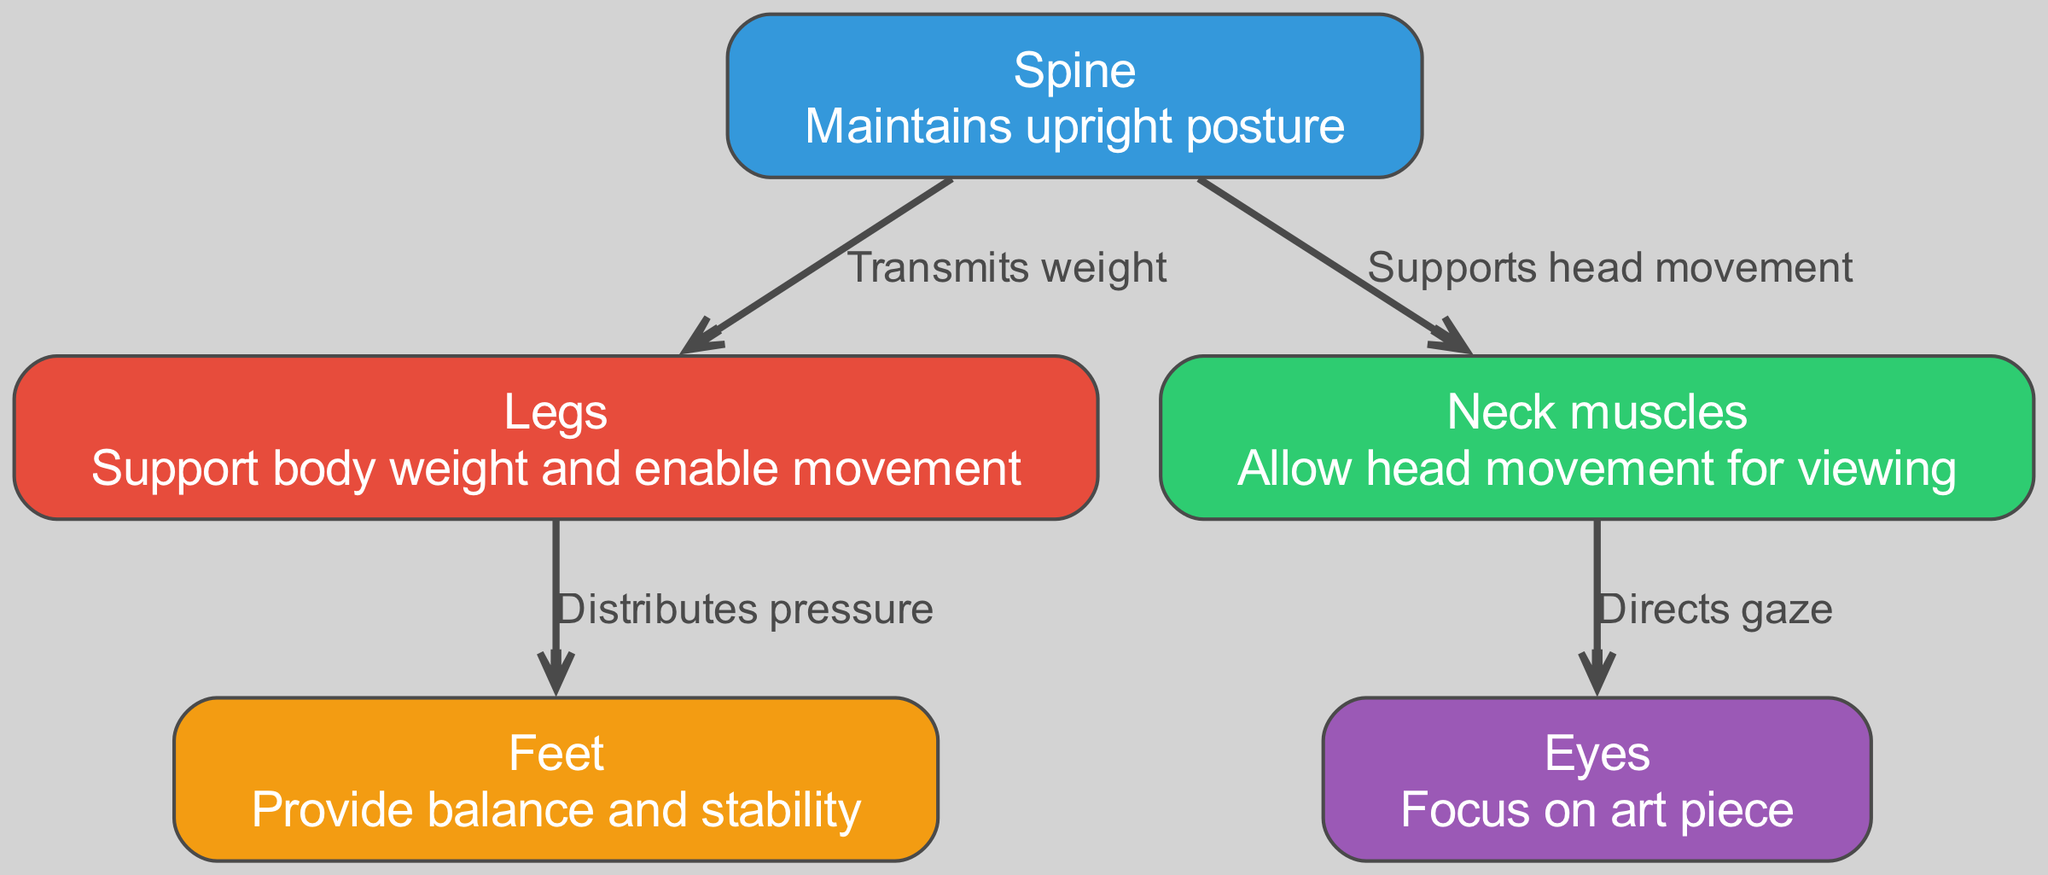What are the major components of the musculoskeletal system depicted? The nodes in the diagram represent the major components, which include the spine, legs, neck muscles, feet, and eyes. These are clearly labeled in the diagram.
Answer: Spine, Legs, Neck muscles, Feet, Eyes What role does the spine play in posture? The spine is labeled as maintaining upright posture, indicating its crucial role in supporting the body while standing or walking.
Answer: Maintains upright posture How do the legs interact with the feet? According to the diagram, the relationship is indicated by the edge labeled "Distributes pressure," meaning the legs help in distributing body weight to the feet.
Answer: Distributes pressure Which node is responsible for directing gaze toward the art piece? The arrow connected from the neck indicates that it directs gaze to the eyes, which are responsible for focusing on the art piece.
Answer: Eyes What is the total number of nodes in the diagram? Counting the nodes listed in the diagram, there are five nodes: spine, legs, neck muscles, feet, and eyes.
Answer: Five How does the spine influence the neck muscles? The edge labeled "Supports head movement" connects the spine to the neck muscles, suggesting that the spine enables the movement of the head facilitated by the neck muscles.
Answer: Supports head movement Which node provides balance and stability? The label for feet in the diagram states that they provide balance and stability, emphasizing their importance in maintaining posture while viewing art.
Answer: Feet What is the connection between legs and weight? The edge between spine and legs, labeled "Transmits weight," shows that the legs are integral in supporting the weight of the body, which is transmitted through the spine.
Answer: Transmits weight How many edges are present in the diagram? By counting the directed edges that connect the nodes, there are four edges in total that indicate the relationships between the components.
Answer: Four 